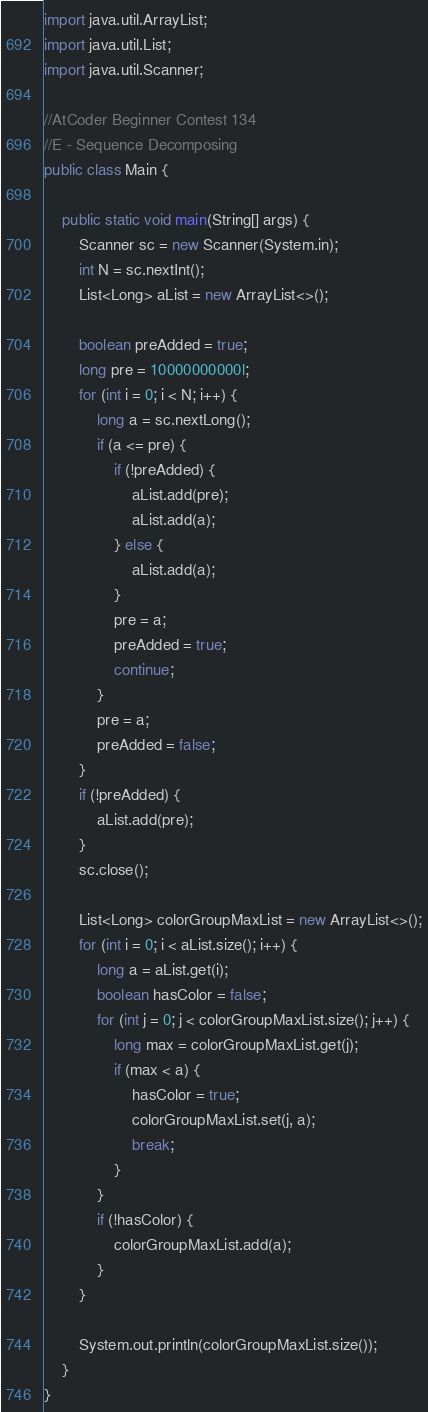<code> <loc_0><loc_0><loc_500><loc_500><_Java_>import java.util.ArrayList;
import java.util.List;
import java.util.Scanner;

//AtCoder Beginner Contest 134
//E - Sequence Decomposing
public class Main {

	public static void main(String[] args) {
		Scanner sc = new Scanner(System.in);
		int N = sc.nextInt();
		List<Long> aList = new ArrayList<>();

		boolean preAdded = true;
		long pre = 10000000000l;
		for (int i = 0; i < N; i++) {
			long a = sc.nextLong();
			if (a <= pre) {
				if (!preAdded) {
					aList.add(pre);
					aList.add(a);
				} else {
					aList.add(a);
				}
				pre = a;
				preAdded = true;
				continue;
			}
			pre = a;
			preAdded = false;
		}
		if (!preAdded) {
			aList.add(pre);
		}
		sc.close();

		List<Long> colorGroupMaxList = new ArrayList<>();
		for (int i = 0; i < aList.size(); i++) {
			long a = aList.get(i);
			boolean hasColor = false;
			for (int j = 0; j < colorGroupMaxList.size(); j++) {
				long max = colorGroupMaxList.get(j);
				if (max < a) {
					hasColor = true;
					colorGroupMaxList.set(j, a);
					break;
				}
			}
			if (!hasColor) {
				colorGroupMaxList.add(a);
			}
		}

		System.out.println(colorGroupMaxList.size());
	}
}
</code> 